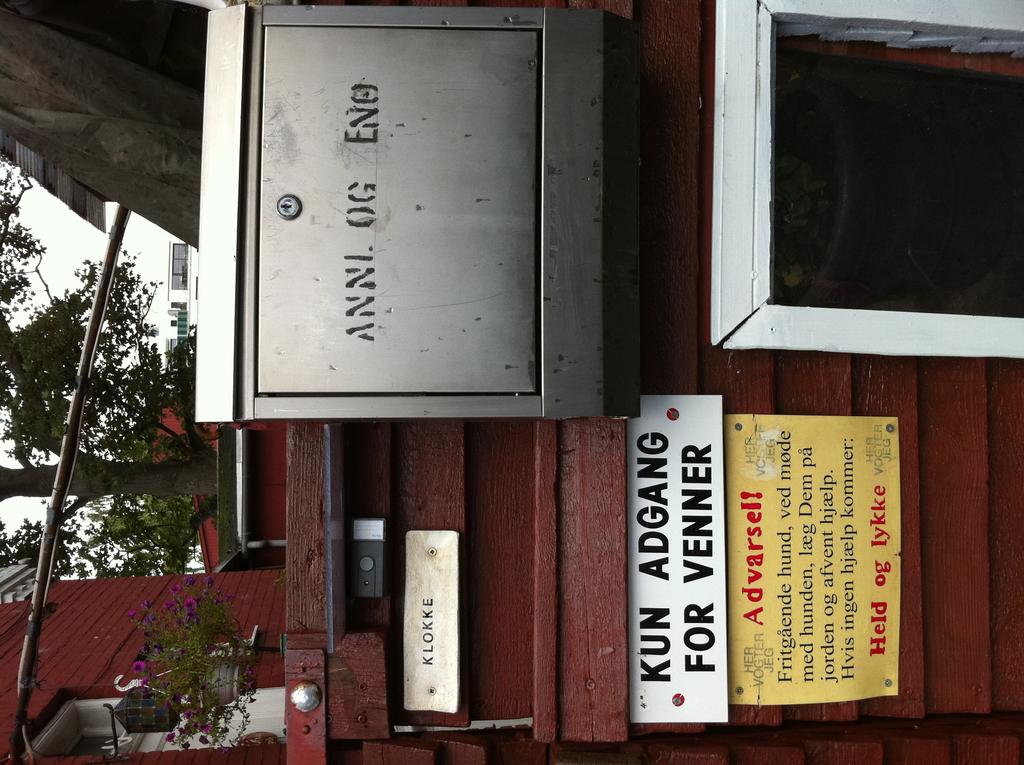What type of storage or organization unit can be seen in the image? There is a locker in the image. What is on the wooden surface in the image? There are boards on the wooden surface. What type of plant is present in the background of the image? There is a plant with a pot in the background. What additional elements can be seen in the background of the image? Flowers, lights, houses, a tree, and the sky are visible in the background. How does the oven feel about the day in the image? There is no oven present in the image, so it is not possible to determine how it might feel about the day. 